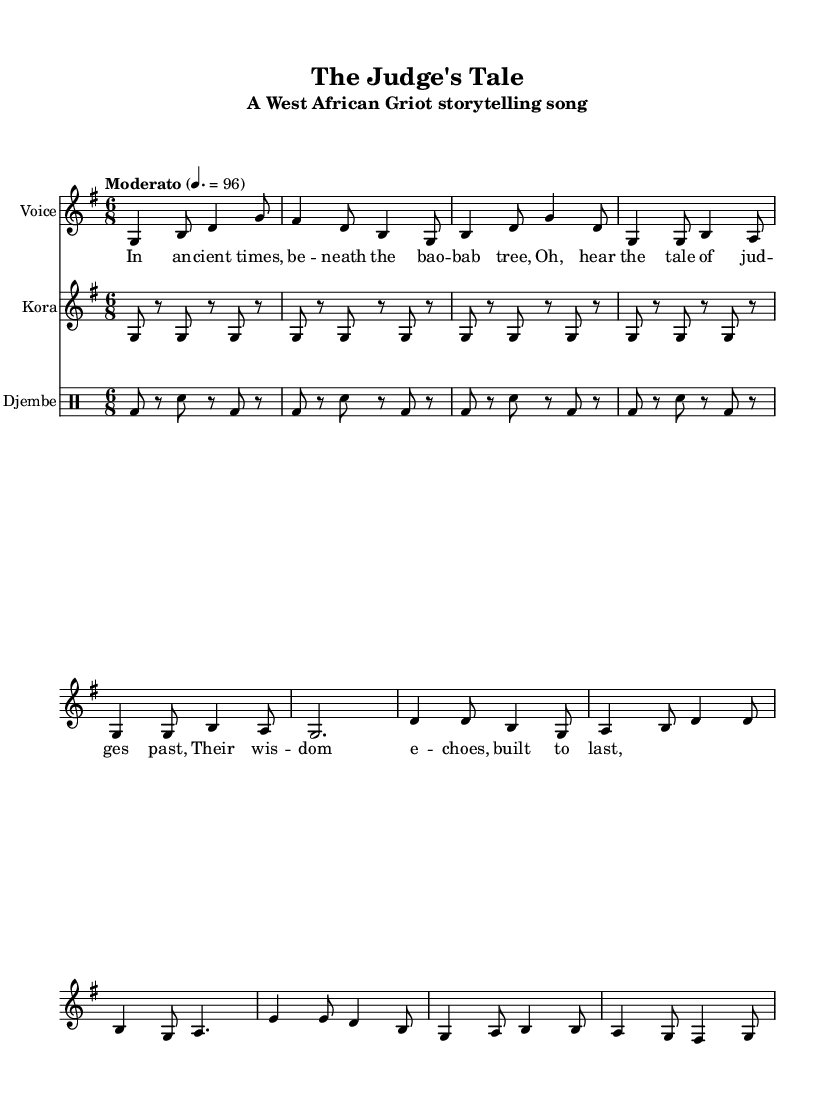What is the key signature of this music? The key signature is G major, which has one sharp (F#). This is indicated in the global settings at the top of the sheet music.
Answer: G major What is the time signature of this music? The time signature is 6/8, which means there are six eighth notes per measure. This is specified in the global settings as well.
Answer: 6/8 What is the tempo marking for this piece? The tempo marking is Moderato, indicated by the textual tempo instruction in the global settings. It specifies a speed of 96 beats per minute.
Answer: Moderato How many measures are in the chorus section? The chorus section consists of three measures, as observed from the structure of the melody and the presence of three distinct phrases.
Answer: 3 Identify the primary instrument used for melody in this piece. The primary instrument used for melody is the Voice, as indicated by the staff label and the notation of notes above the lyrics.
Answer: Voice What type of rhythm is predominantly used in the djembe part? The rhythm used in the djembe part is a basic bass-drum/snare pattern, characterized by the alternation of bass notes and rests in a consistent repeat.
Answer: Bass-drum/snare pattern What traditional storytelling element is present in the lyrics? The lyrics reflect a historical narrative, specifically focusing on the tales of judges from ancient times, which is a characteristic feature of griot storytelling.
Answer: Historical narrative 